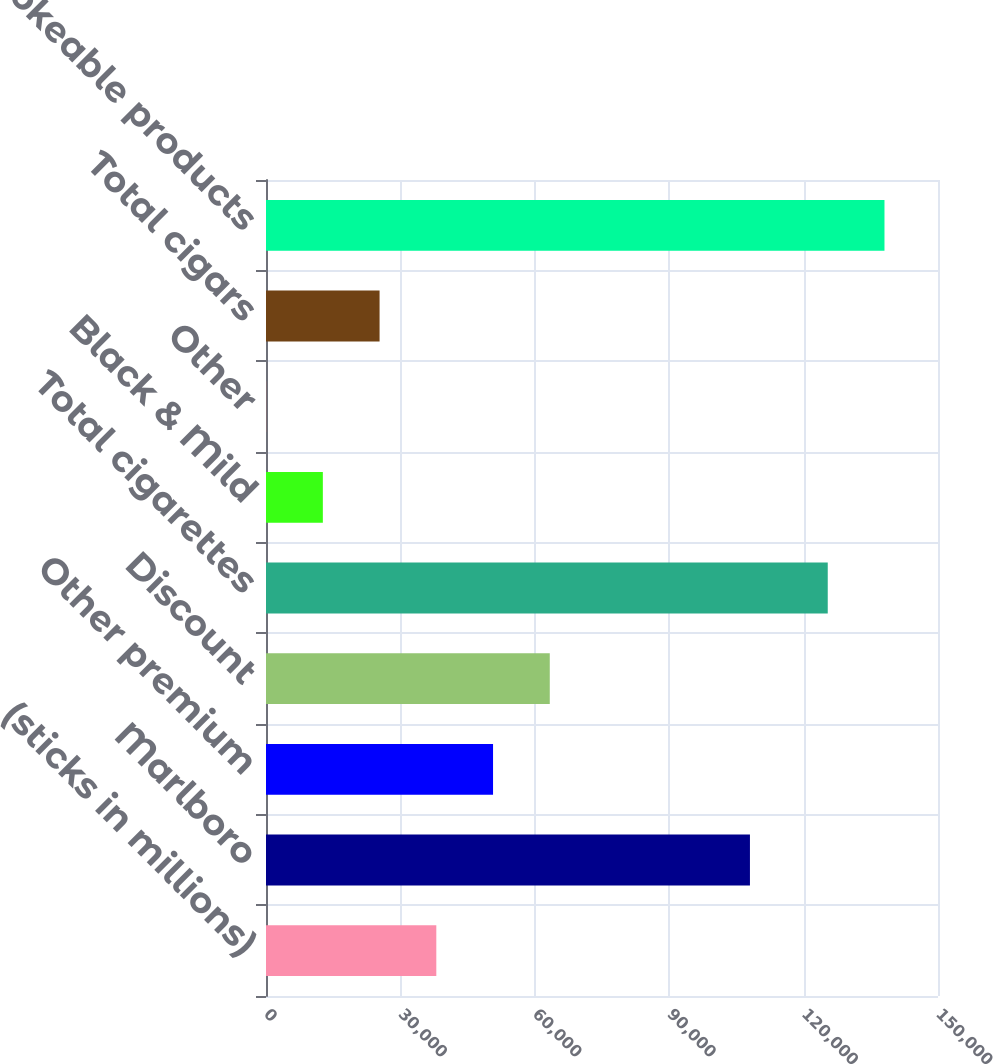Convert chart to OTSL. <chart><loc_0><loc_0><loc_500><loc_500><bar_chart><fcel>(sticks in millions)<fcel>Marlboro<fcel>Other premium<fcel>Discount<fcel>Total cigarettes<fcel>Black & Mild<fcel>Other<fcel>Total cigars<fcel>Total smokeable products<nl><fcel>38015.8<fcel>108023<fcel>50679.4<fcel>63343<fcel>125390<fcel>12688.6<fcel>25<fcel>25352.2<fcel>138054<nl></chart> 